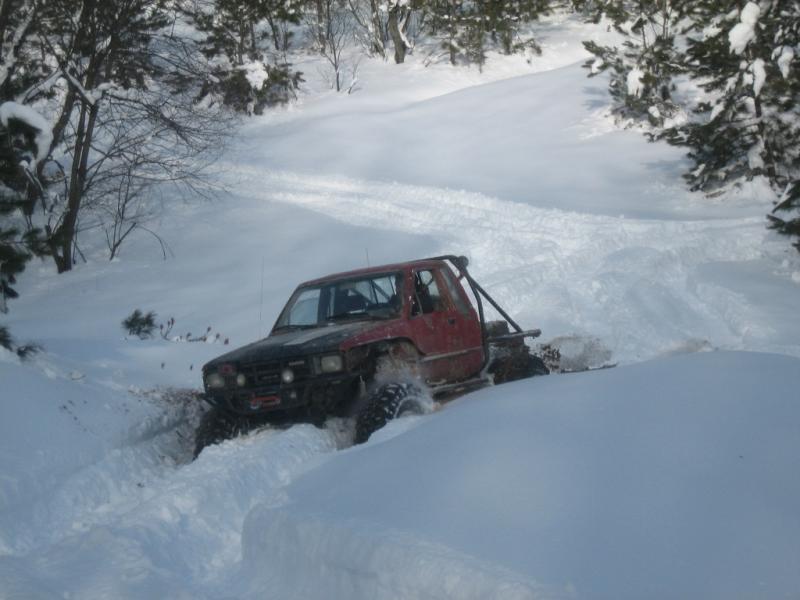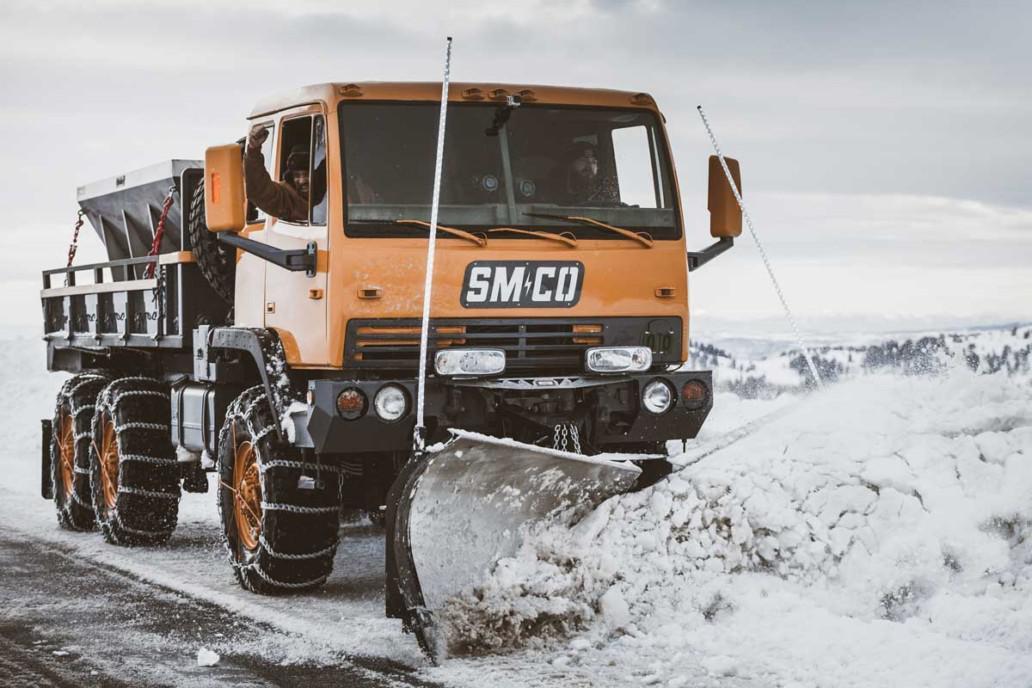The first image is the image on the left, the second image is the image on the right. Given the left and right images, does the statement "At least one of the trucks is pushing a yellow plow through the snow." hold true? Answer yes or no. No. 